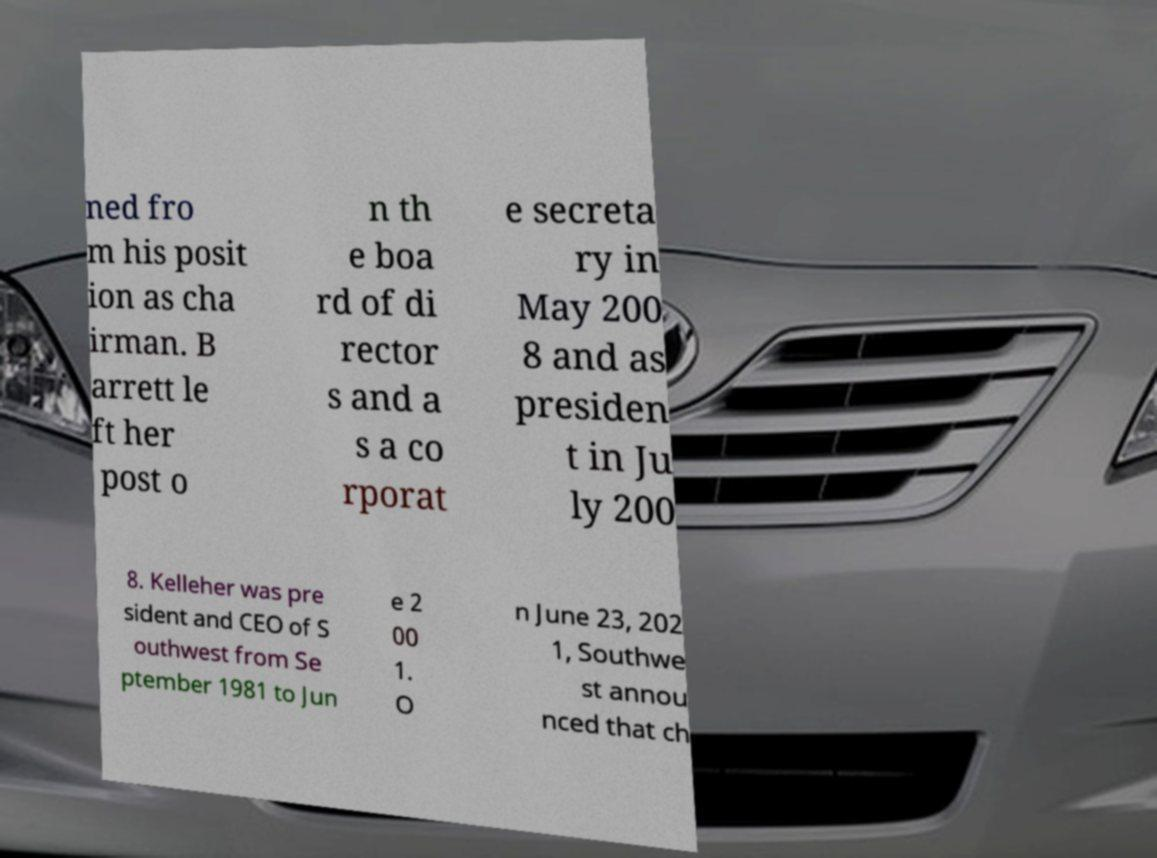Please identify and transcribe the text found in this image. ned fro m his posit ion as cha irman. B arrett le ft her post o n th e boa rd of di rector s and a s a co rporat e secreta ry in May 200 8 and as presiden t in Ju ly 200 8. Kelleher was pre sident and CEO of S outhwest from Se ptember 1981 to Jun e 2 00 1. O n June 23, 202 1, Southwe st annou nced that ch 